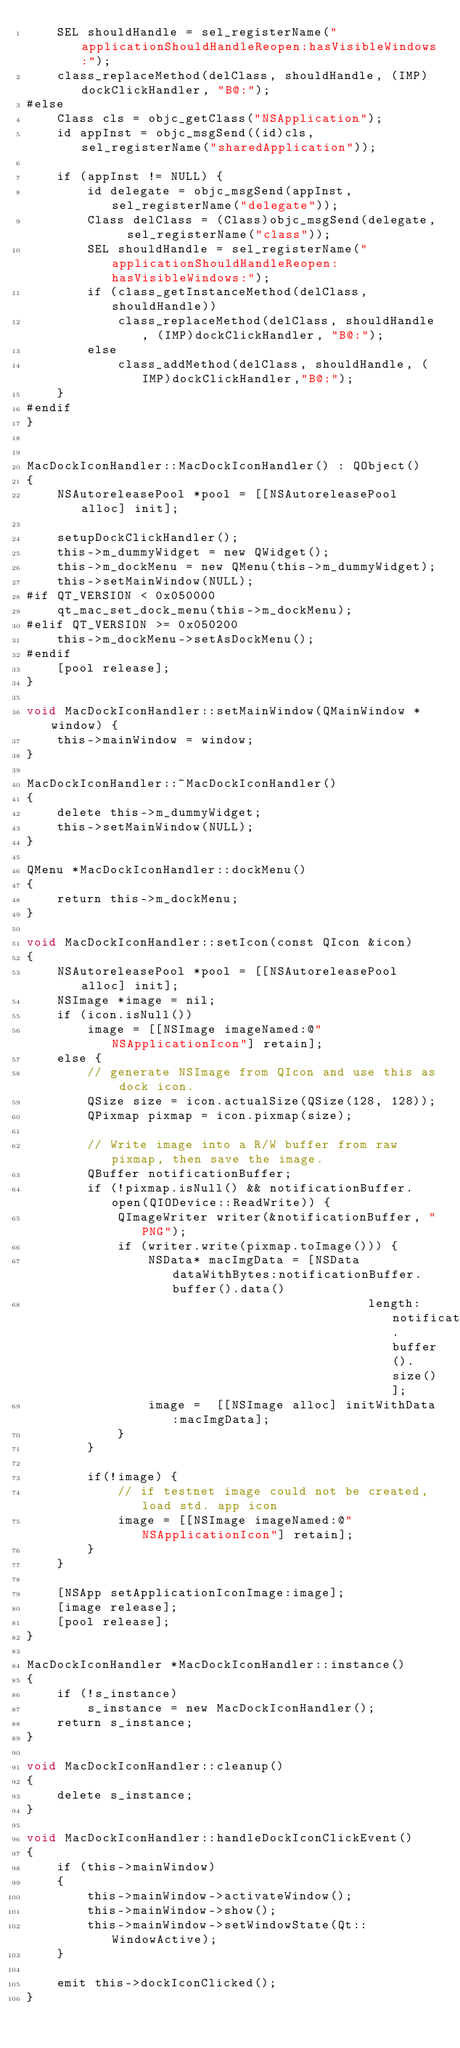<code> <loc_0><loc_0><loc_500><loc_500><_ObjectiveC_>    SEL shouldHandle = sel_registerName("applicationShouldHandleReopen:hasVisibleWindows:");
    class_replaceMethod(delClass, shouldHandle, (IMP)dockClickHandler, "B@:");
#else
    Class cls = objc_getClass("NSApplication");
    id appInst = objc_msgSend((id)cls, sel_registerName("sharedApplication"));
    
    if (appInst != NULL) {
        id delegate = objc_msgSend(appInst, sel_registerName("delegate"));
        Class delClass = (Class)objc_msgSend(delegate,  sel_registerName("class"));
        SEL shouldHandle = sel_registerName("applicationShouldHandleReopen:hasVisibleWindows:");
        if (class_getInstanceMethod(delClass, shouldHandle))
            class_replaceMethod(delClass, shouldHandle, (IMP)dockClickHandler, "B@:");
        else
            class_addMethod(delClass, shouldHandle, (IMP)dockClickHandler,"B@:");
    }
#endif
}


MacDockIconHandler::MacDockIconHandler() : QObject()
{
    NSAutoreleasePool *pool = [[NSAutoreleasePool alloc] init];

    setupDockClickHandler();
    this->m_dummyWidget = new QWidget();
    this->m_dockMenu = new QMenu(this->m_dummyWidget);
    this->setMainWindow(NULL);
#if QT_VERSION < 0x050000
    qt_mac_set_dock_menu(this->m_dockMenu);
#elif QT_VERSION >= 0x050200
    this->m_dockMenu->setAsDockMenu();
#endif
    [pool release];
}

void MacDockIconHandler::setMainWindow(QMainWindow *window) {
    this->mainWindow = window;
}

MacDockIconHandler::~MacDockIconHandler()
{
    delete this->m_dummyWidget;
    this->setMainWindow(NULL);
}

QMenu *MacDockIconHandler::dockMenu()
{
    return this->m_dockMenu;
}

void MacDockIconHandler::setIcon(const QIcon &icon)
{
    NSAutoreleasePool *pool = [[NSAutoreleasePool alloc] init];
    NSImage *image = nil;
    if (icon.isNull())
        image = [[NSImage imageNamed:@"NSApplicationIcon"] retain];
    else {
        // generate NSImage from QIcon and use this as dock icon.
        QSize size = icon.actualSize(QSize(128, 128));
        QPixmap pixmap = icon.pixmap(size);

        // Write image into a R/W buffer from raw pixmap, then save the image.
        QBuffer notificationBuffer;
        if (!pixmap.isNull() && notificationBuffer.open(QIODevice::ReadWrite)) {
            QImageWriter writer(&notificationBuffer, "PNG");
            if (writer.write(pixmap.toImage())) {
                NSData* macImgData = [NSData dataWithBytes:notificationBuffer.buffer().data()
                                             length:notificationBuffer.buffer().size()];
                image =  [[NSImage alloc] initWithData:macImgData];
            }
        }

        if(!image) {
            // if testnet image could not be created, load std. app icon
            image = [[NSImage imageNamed:@"NSApplicationIcon"] retain];
        }
    }

    [NSApp setApplicationIconImage:image];
    [image release];
    [pool release];
}

MacDockIconHandler *MacDockIconHandler::instance()
{
    if (!s_instance)
        s_instance = new MacDockIconHandler();
    return s_instance;
}

void MacDockIconHandler::cleanup()
{
    delete s_instance;
}

void MacDockIconHandler::handleDockIconClickEvent()
{
    if (this->mainWindow)
    {
        this->mainWindow->activateWindow();
        this->mainWindow->show();
        this->mainWindow->setWindowState(Qt::WindowActive);
    }

    emit this->dockIconClicked();
}
</code> 